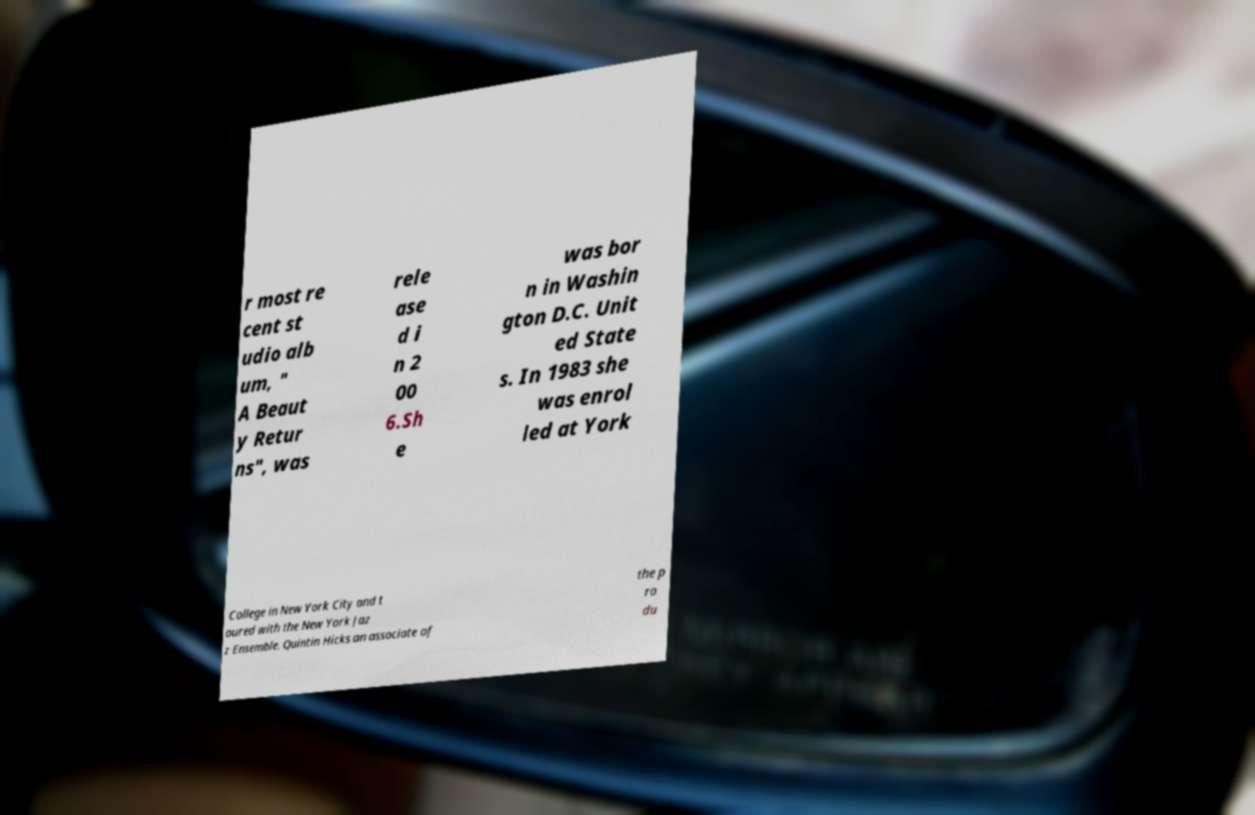Please read and relay the text visible in this image. What does it say? r most re cent st udio alb um, " A Beaut y Retur ns", was rele ase d i n 2 00 6.Sh e was bor n in Washin gton D.C. Unit ed State s. In 1983 she was enrol led at York College in New York City and t oured with the New York Jaz z Ensemble. Quintin Hicks an associate of the p ro du 